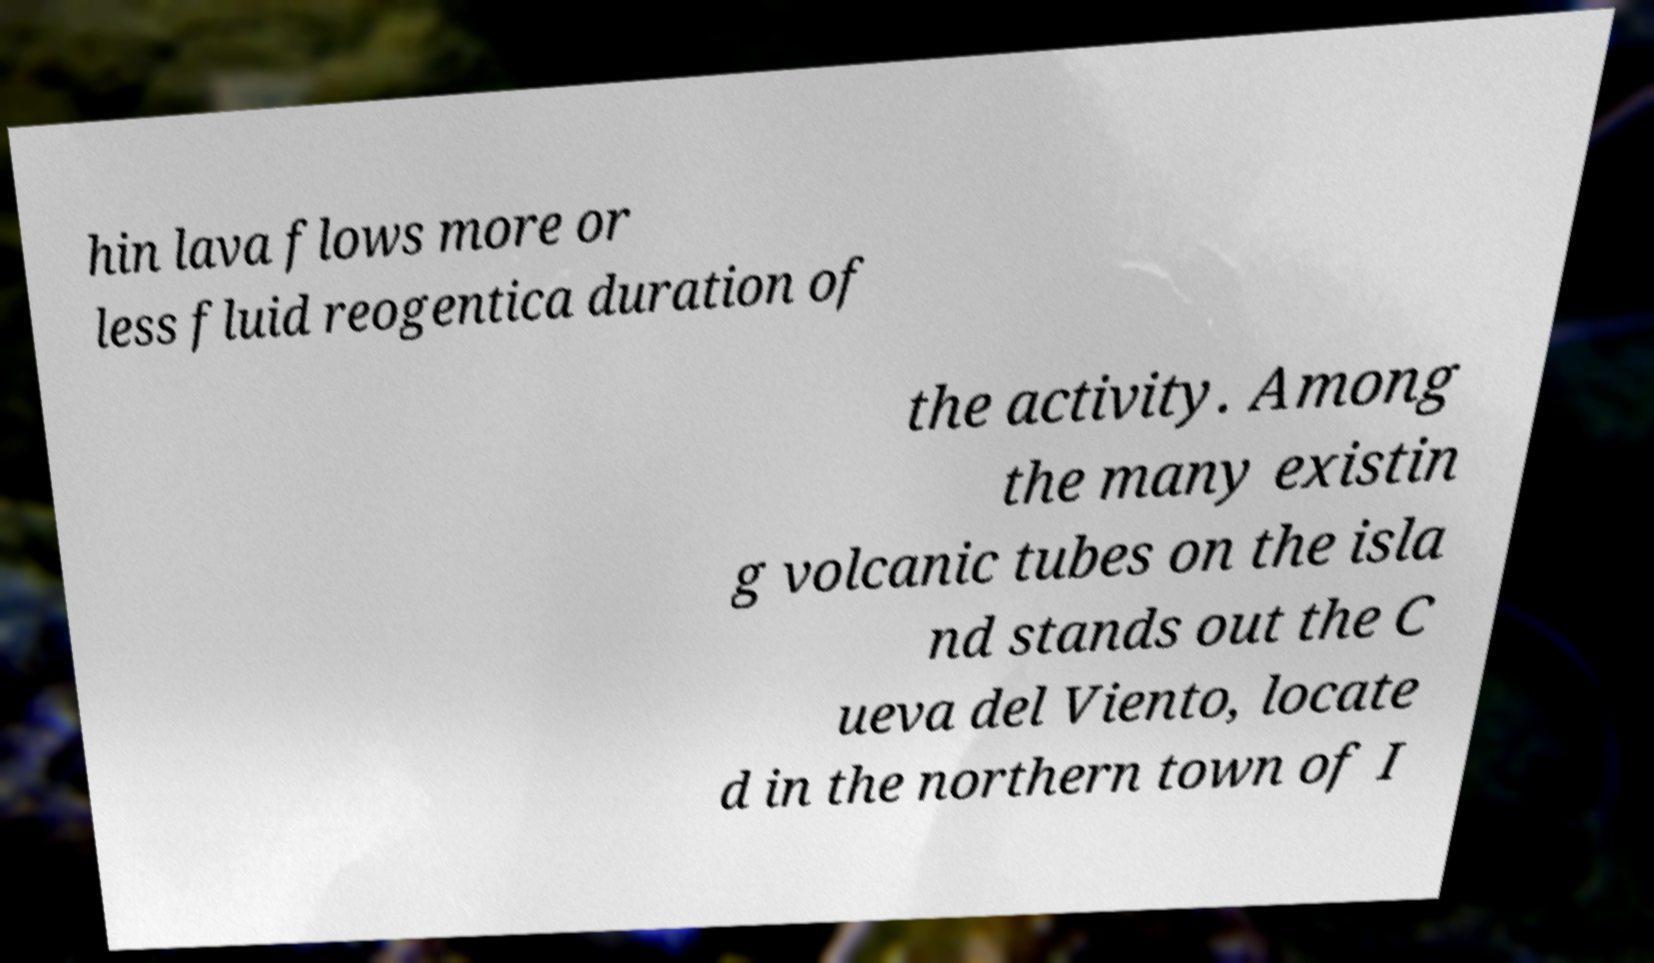I need the written content from this picture converted into text. Can you do that? hin lava flows more or less fluid reogentica duration of the activity. Among the many existin g volcanic tubes on the isla nd stands out the C ueva del Viento, locate d in the northern town of I 